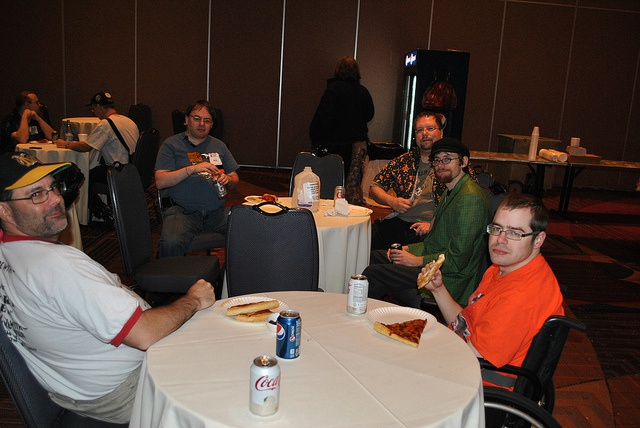Describe the objects in this image and their specific colors. I can see dining table in black, tan, darkgray, and lightgray tones, people in black, darkgray, gray, brown, and lightgray tones, people in black, red, and brown tones, people in black, darkgreen, olive, and brown tones, and people in black, maroon, and brown tones in this image. 